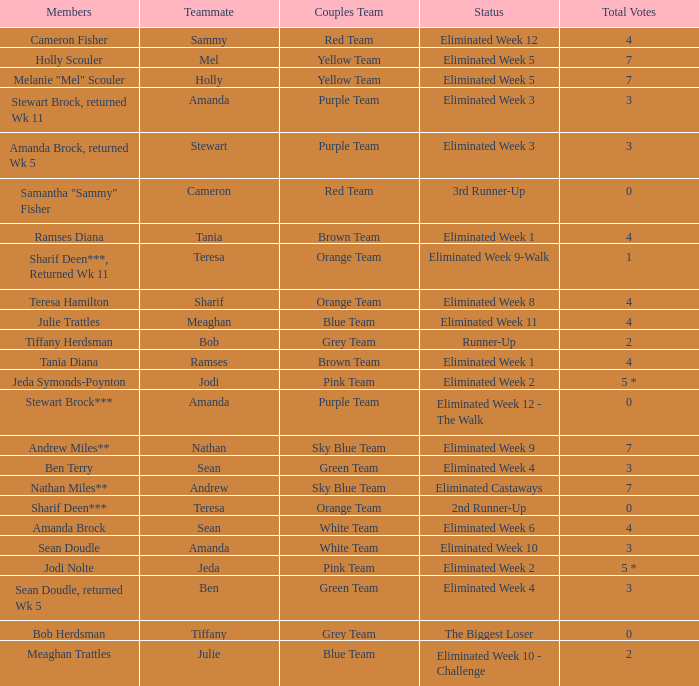What were Holly Scouler's total votes? 7.0. 